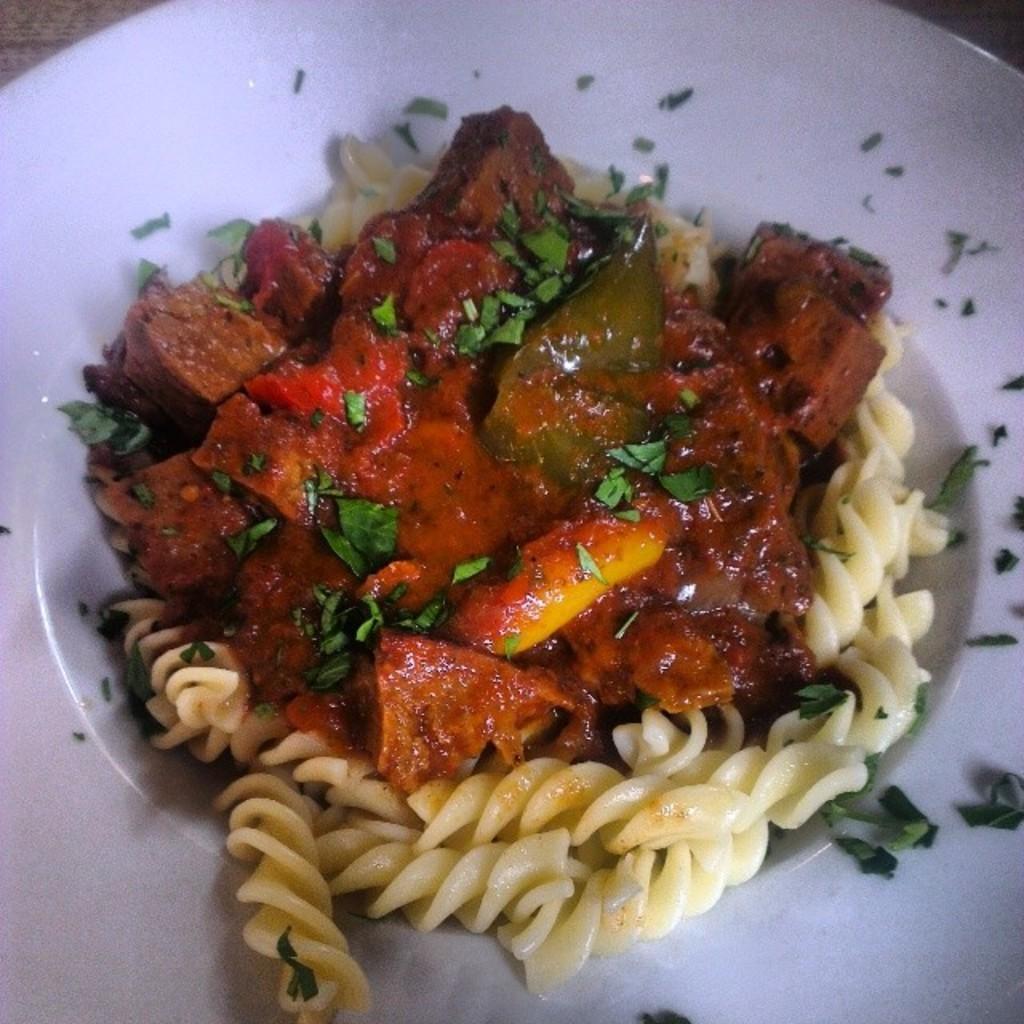Describe this image in one or two sentences. In this image we can see a white plate. On that there is a food item with pasta, pieces of green leaves and some other things. 